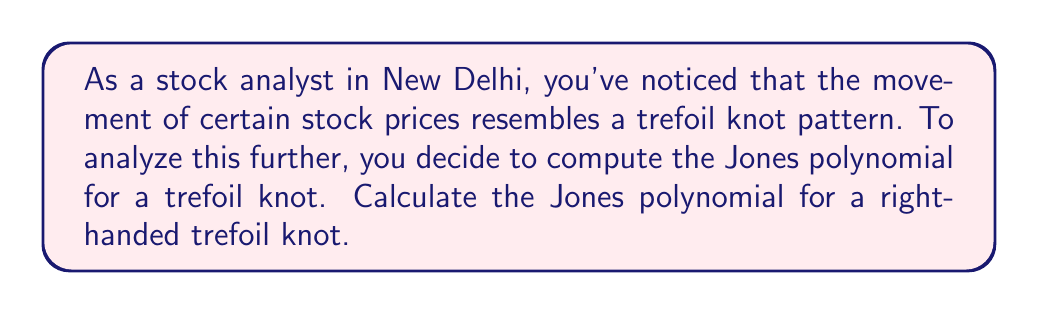Teach me how to tackle this problem. Let's compute the Jones polynomial for a right-handed trefoil knot step by step:

1) First, we need to create the Kauffman bracket polynomial. For a right-handed trefoil knot, we have:

   $$\langle K \rangle = A^{-3} \langle \bigcirc \bigcirc \bigcirc \rangle - A^{-1} \langle \bigcirc \rangle$$

2) We know that $\langle \bigcirc \rangle = -A^2 - A^{-2}$ and $\langle \bigcirc \bigcirc \bigcirc \rangle = (-A^2 - A^{-2})^3$

3) Substituting these values:

   $$\langle K \rangle = A^{-3} (-A^2 - A^{-2})^3 - A^{-1} (-A^2 - A^{-2})$$

4) Expanding the cube:

   $$\langle K \rangle = A^{-3} (-A^6 - 3A^2 - 3A^{-2} - A^{-6}) + A^3 + A^{-1}$$

5) Simplifying:

   $$\langle K \rangle = -A^{-7} + A^{-3} + A^{-1} + A^3$$

6) The writhe of a right-handed trefoil knot is 3. To get the Jones polynomial, we multiply by $(-A^3)^{-3}$:

   $$V_K(t) = (-A^3)^{-3} (-A^{-7} + A^{-3} + A^{-1} + A^3)$$

7) Simplifying and substituting $A^{-4} = t$:

   $$V_K(t) = -t + t^2 - t^3$$

This is the Jones polynomial for a right-handed trefoil knot.
Answer: $V_K(t) = -t + t^2 - t^3$ 